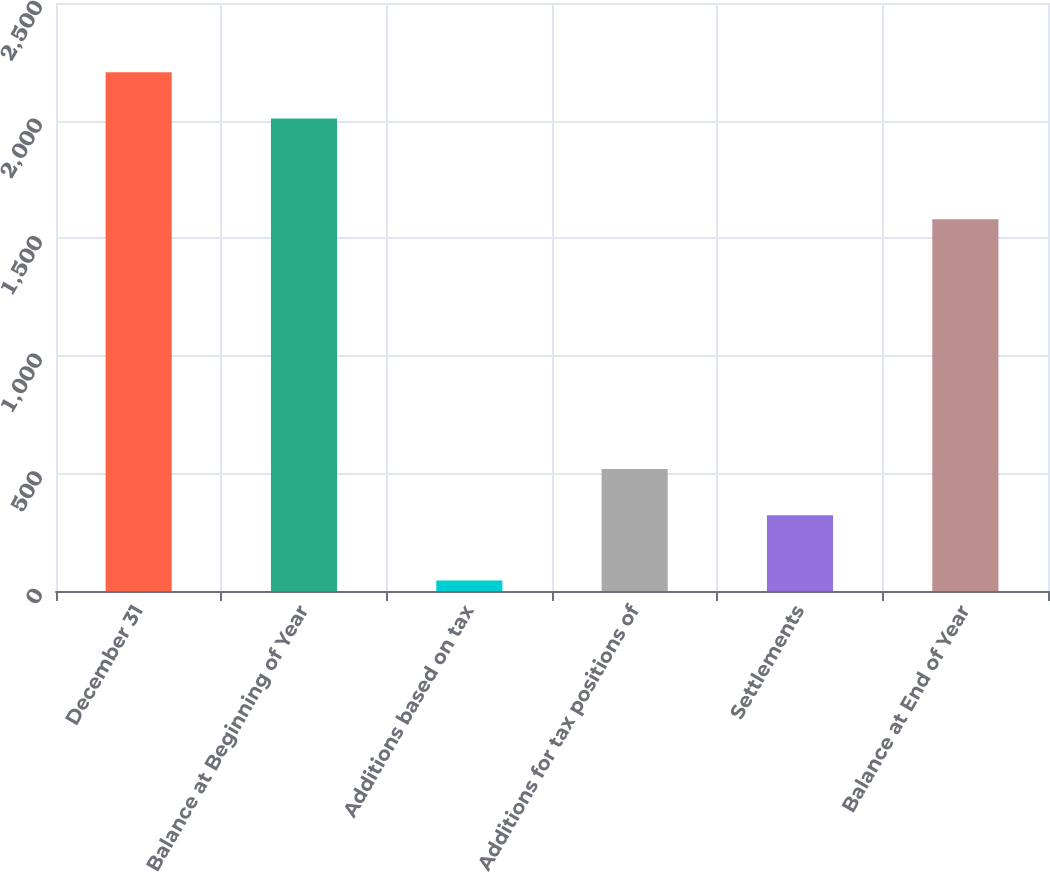Convert chart. <chart><loc_0><loc_0><loc_500><loc_500><bar_chart><fcel>December 31<fcel>Balance at Beginning of Year<fcel>Additions based on tax<fcel>Additions for tax positions of<fcel>Settlements<fcel>Balance at End of Year<nl><fcel>2205.7<fcel>2009<fcel>45<fcel>518.7<fcel>322<fcel>1581<nl></chart> 